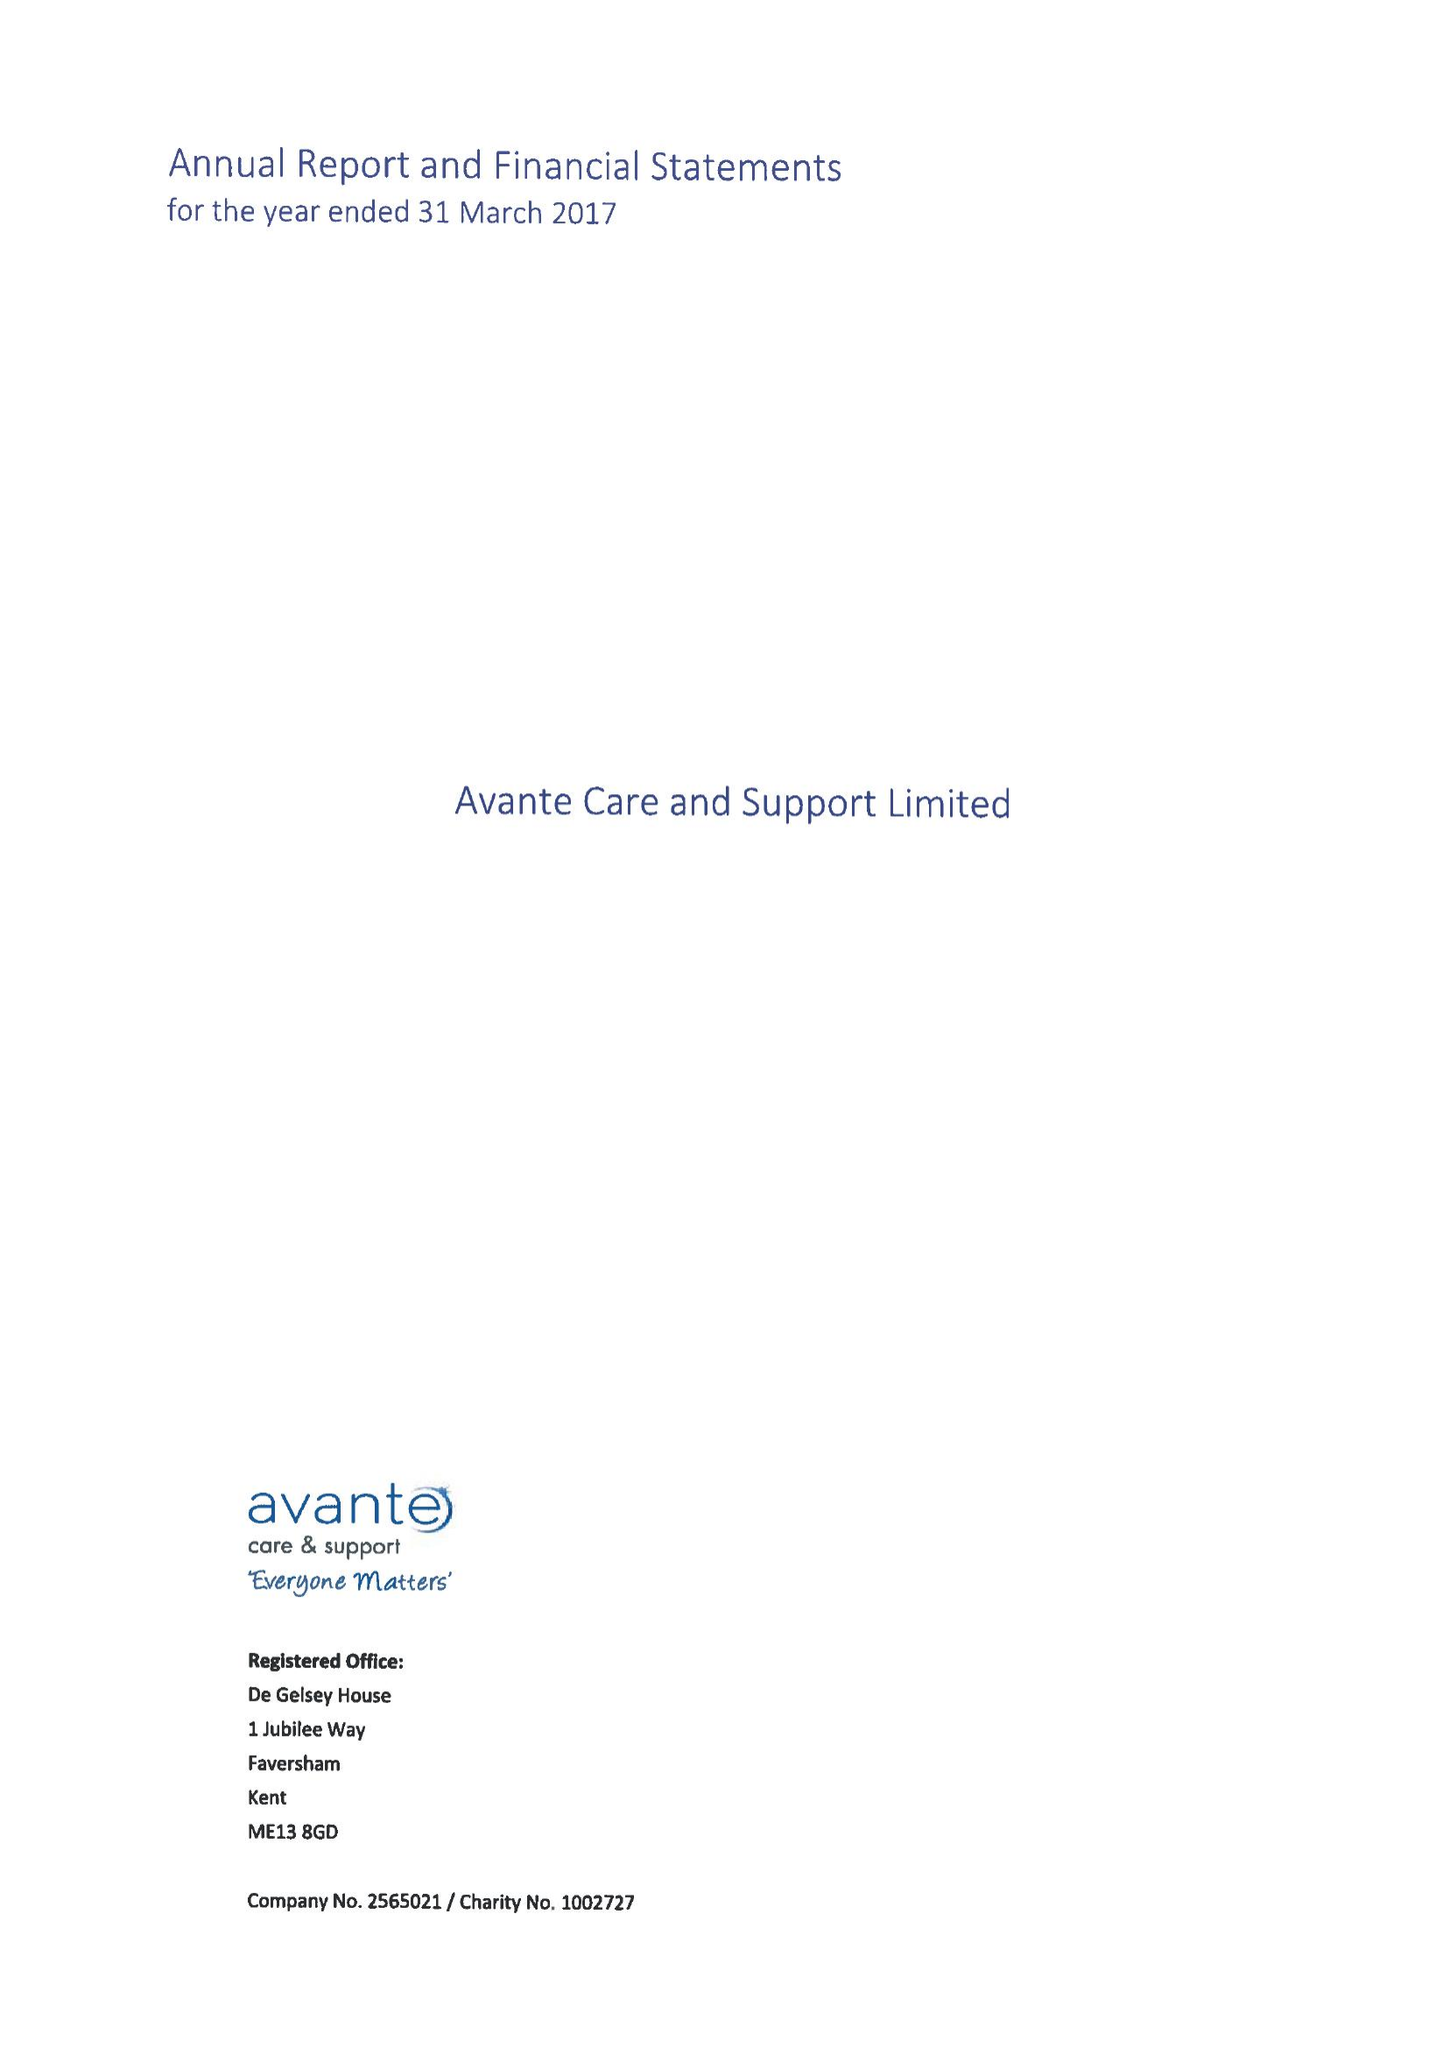What is the value for the address__post_town?
Answer the question using a single word or phrase. FAVERSHAM 